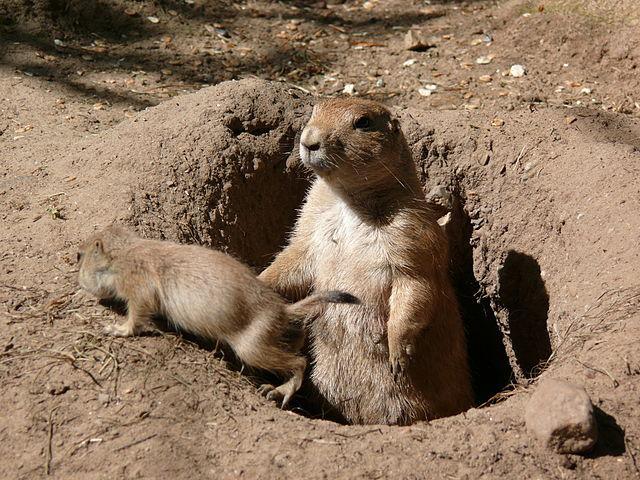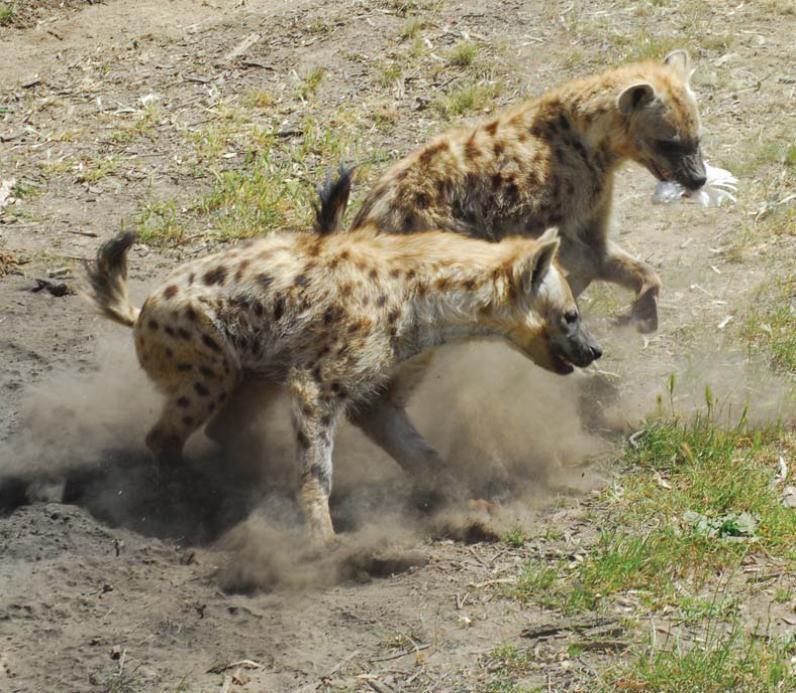The first image is the image on the left, the second image is the image on the right. For the images displayed, is the sentence "There are two hyenas facing right." factually correct? Answer yes or no. Yes. 